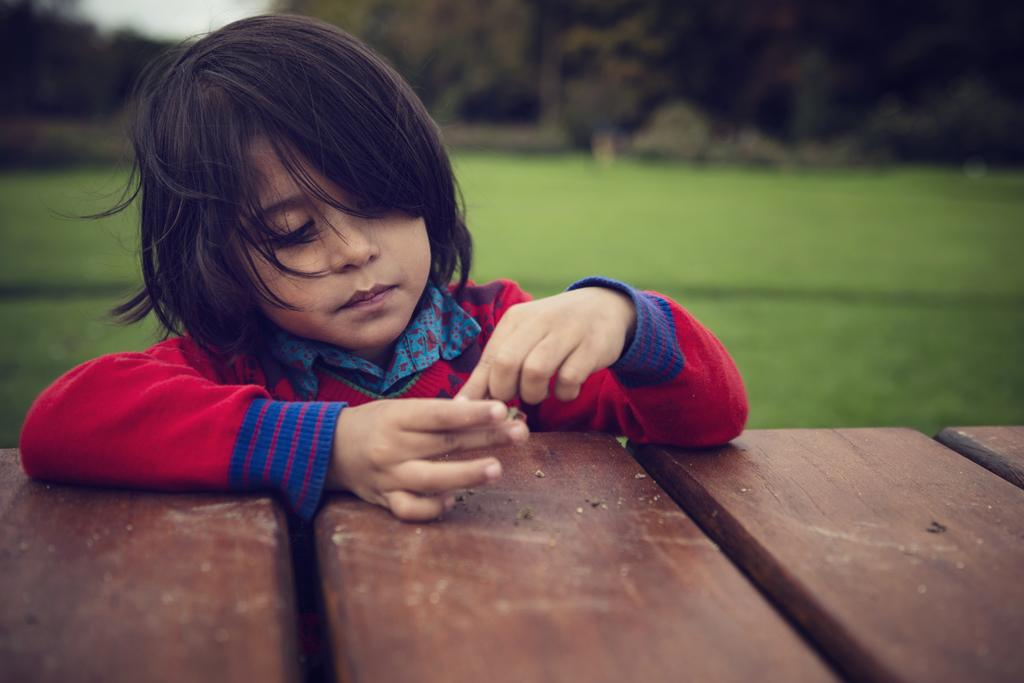What type of seating is visible in the image? There is a bench in the image. Who is present in the image? There is a boy in the image. What is the boy wearing? The boy is wearing a white jacket. What type of natural environment is visible in the image? There is grass and trees in the image. How would you describe the background of the image? The background of the image is blurred. Is there a mailbox visible in the image? No, there is no mailbox present in the image. What type of space exploration is depicted in the image? There is no space exploration depicted in the image; it features a bench, a boy, and natural surroundings. 